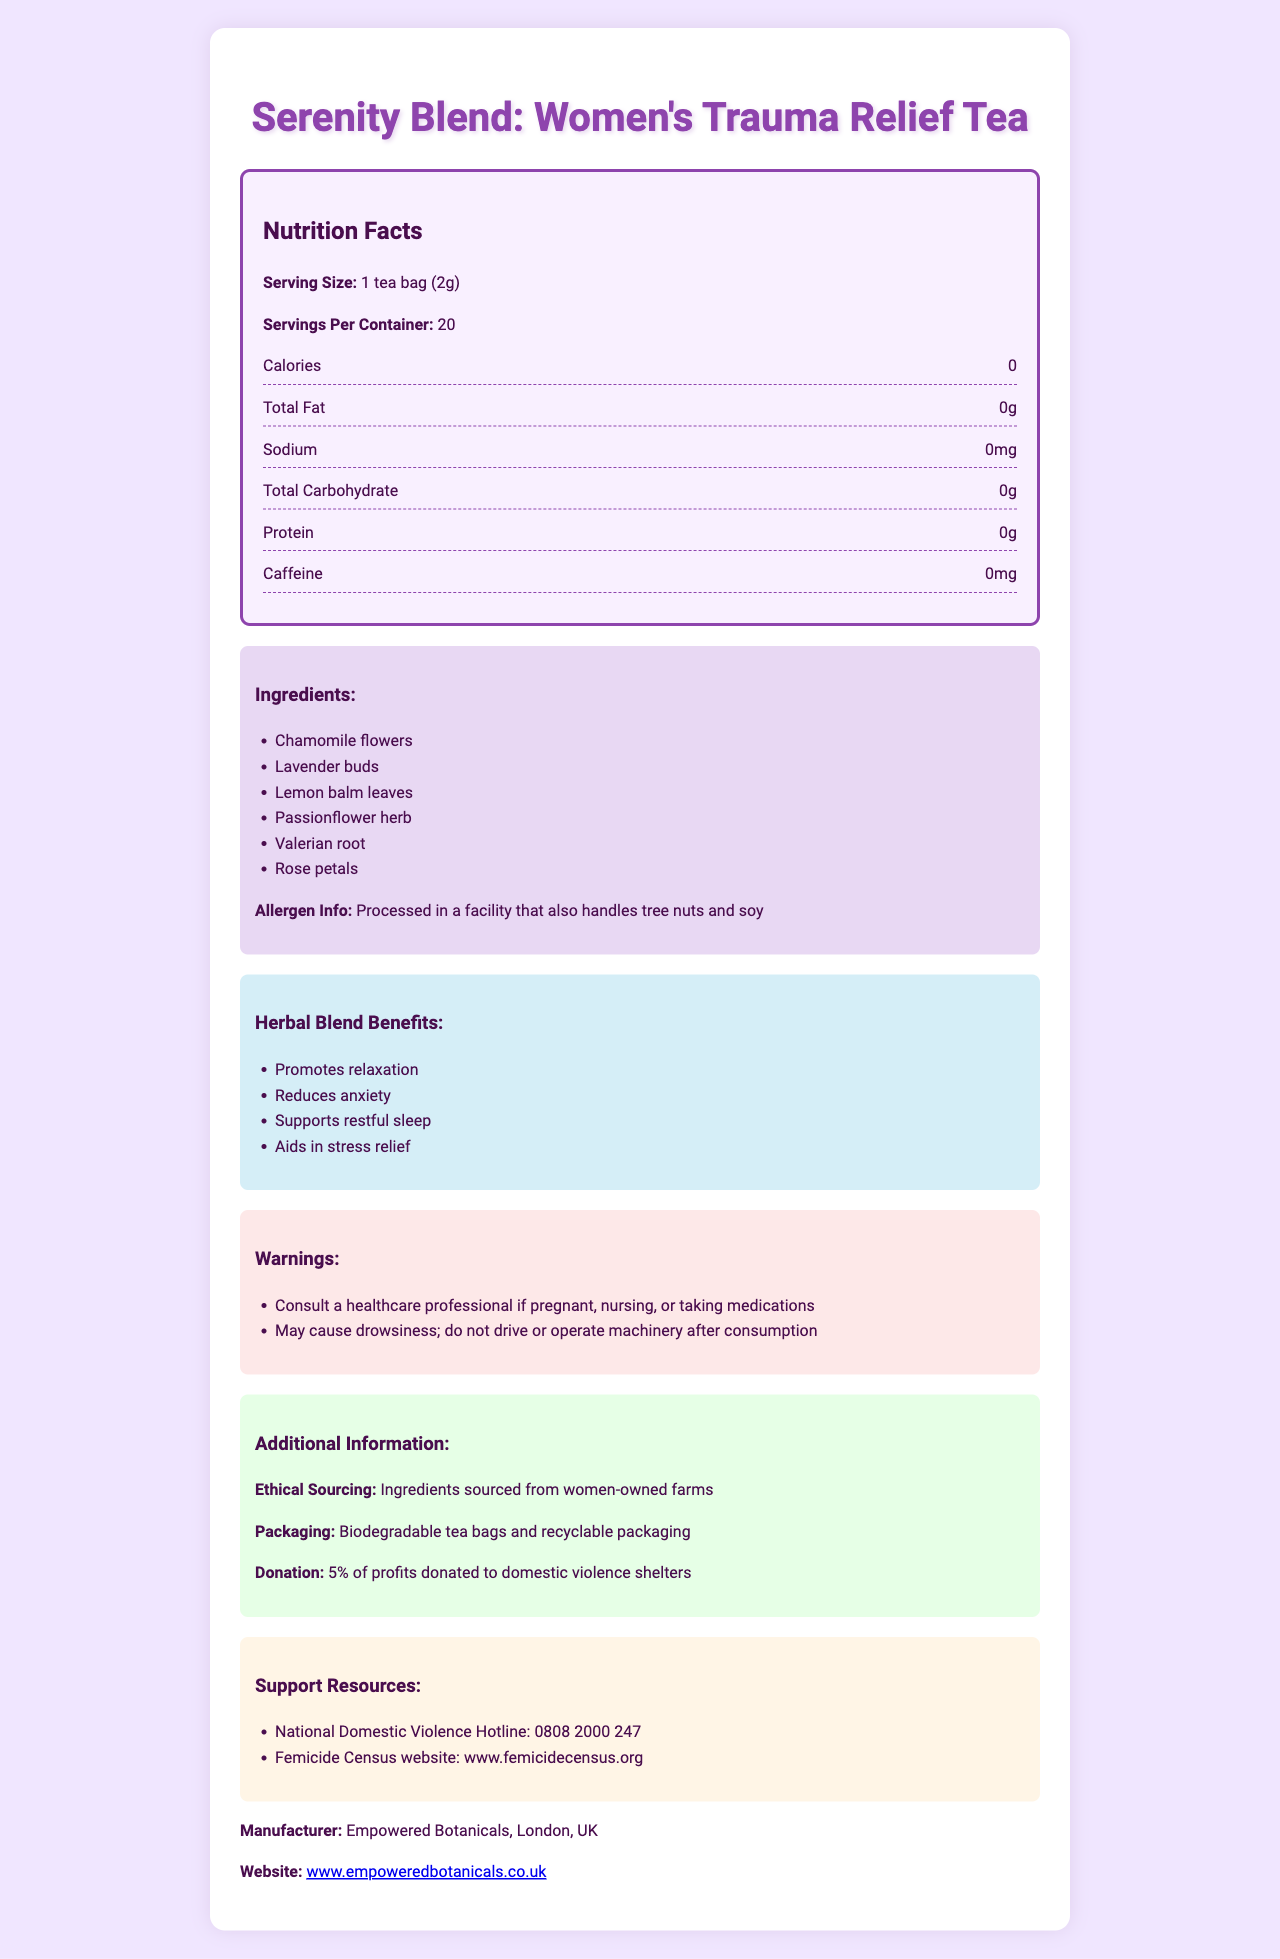What is the serving size for "Serenity Blend: Women's Trauma Relief Tea"? The serving size is explicitly mentioned as "1 tea bag (2g)" in the document.
Answer: 1 tea bag (2g) How many servings are there per container of "Serenity Blend: Women's Trauma Relief Tea"? The document states that there are 20 servings per container.
Answer: 20 How many calories are in one serving of the tea? The Nutrition Facts section lists the calorie content as 0.
Answer: 0 What are the ingredients in "Serenity Blend: Women's Trauma Relief Tea"? The ingredients are listed in the ingredients section of the document.
Answer: Chamomile flowers, Lavender buds, Lemon balm leaves, Passionflower herb, Valerian root, Rose petals What are the benefits of the herbal blend in the tea? The benefits are listed under the "Herbal Blend Benefits" section.
Answer: Promotes relaxation, Reduces anxiety, Supports restful sleep, Aids in stress relief Is there any caffeine in "Serenity Blend: Women's Trauma Relief Tea"? The document states that the caffeine content is 0mg.
Answer: No Where are the ingredients for the tea sourced from? A. Local farms B. Women-owned farms C. Organic farms D. International farms The document specifies that the ingredients are sourced from women-owned farms.
Answer: B How should one prepare the tea? A. Steep one tea bag in 12 oz of hot water for 5-7 minutes B. Boil one tea bag in water for 10 minutes C. Steep one tea bag in 8 oz of hot water for 5-7 minutes D. Microwave one tea bag in water for 2 minutes The preparation instructions indicate to steep one tea bag in 8 oz of hot water for 5-7 minutes.
Answer: C Can you consume "Serenity Blend: Women's Trauma Relief Tea" if you are taking medications without consulting a healthcare professional? (Yes/No) One of the warnings advises consulting a healthcare professional if taking medications.
Answer: No What ethical sourcing information is provided about the tea? The document states that the ingredients are sourced from women-owned farms.
Answer: Ingredients sourced from women-owned farms What additional support resources are mentioned in the document? These support resources are listed under the "Support Resources" section of the document.
Answer: National Domestic Violence Hotline: 0808 2000 247, Femicide Census website: www.femicidecensus.org What kind of packaging is used for "Serenity Blend: Women's Trauma Relief Tea"? The packaging information specifies biodegradable tea bags and recyclable packaging.
Answer: Biodegradable tea bags and recyclable packaging What donation initiative is associated with this tea product? The donation information states that 5% of profits are donated to domestic violence shelters.
Answer: 5% of profits donated to domestic violence shelters What might someone need to be aware of regarding allergens when consuming this tea? The allergen information notes that the tea is processed in a facility that handles tree nuts and soy.
Answer: Processed in a facility that also handles tree nuts and soy Summarize the main idea of the document. The document provides comprehensive information about the calming herbal tea, including its benefits, ingredients, preparation method, and social impact. It addresses health precautions, and ethical considerations, and offers support for trauma survivors.
Answer: "Serenity Blend: Women's Trauma Relief Tea" is a caffeine-free herbal tea blend designed to promote relaxation, reduce anxiety, and support restful sleep. It contains ingredients like chamomile flowers, lavender buds, and valerian root. The tea is ethically sourced from women-owned farms, packaged in biodegradable materials, and supports domestic violence shelters with a portion of its profits. The document also lists preparation instructions, allergen information, and support resources. What is the source of the HTML and CSS code used to create the Nutrition Facts Label? The HTML and CSS code details are not provided in the visual document, so this information cannot be determined.
Answer: Not enough information 